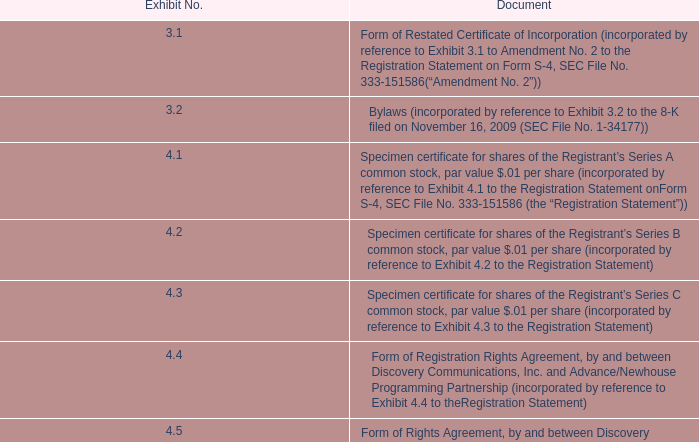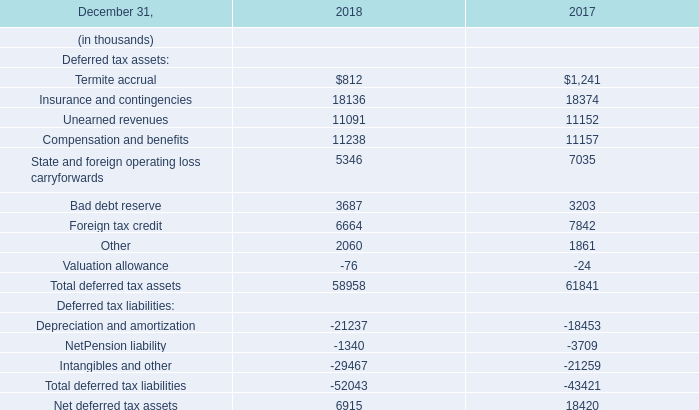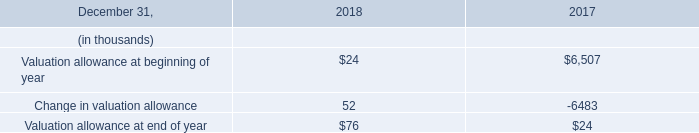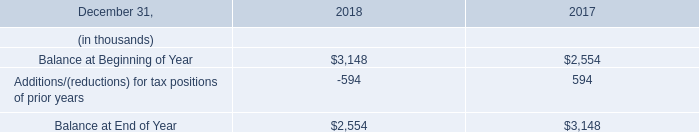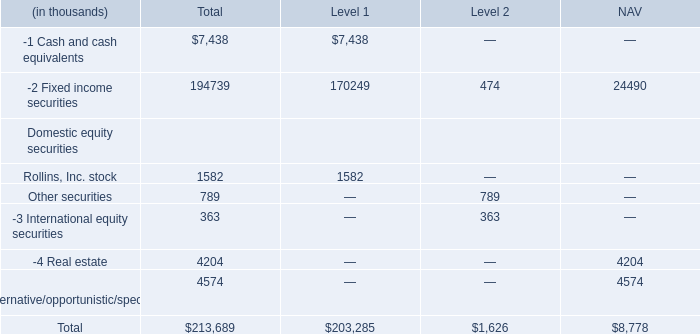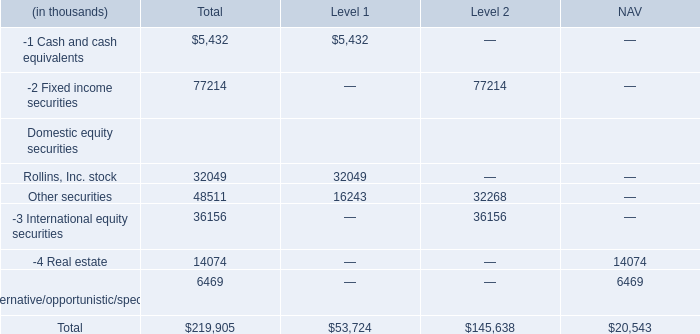As As the chart 4 shows,in which Level is the value of Fixed income securities the lowest? 
Answer: 2. 